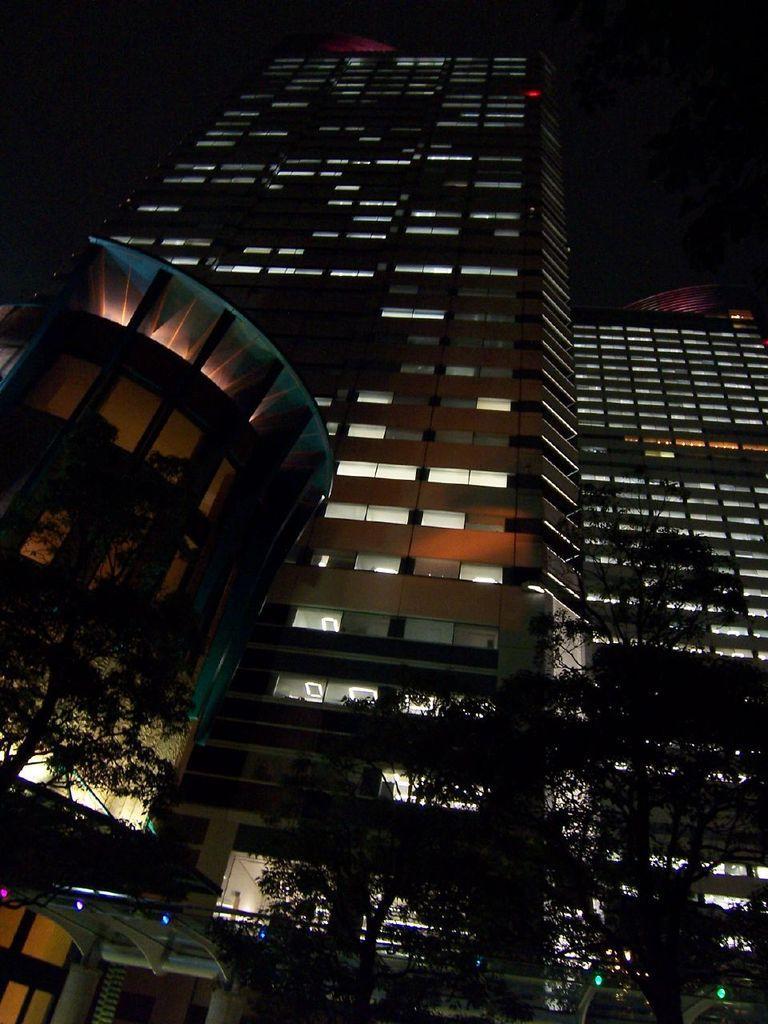In one or two sentences, can you explain what this image depicts? In this image we can see buildings with lights. At the bottom there are trees. In the background it is dark. 